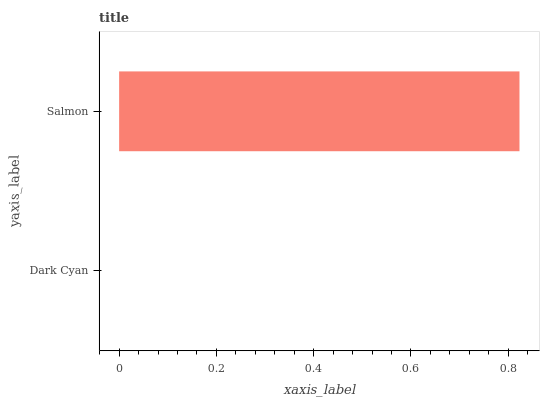Is Dark Cyan the minimum?
Answer yes or no. Yes. Is Salmon the maximum?
Answer yes or no. Yes. Is Salmon the minimum?
Answer yes or no. No. Is Salmon greater than Dark Cyan?
Answer yes or no. Yes. Is Dark Cyan less than Salmon?
Answer yes or no. Yes. Is Dark Cyan greater than Salmon?
Answer yes or no. No. Is Salmon less than Dark Cyan?
Answer yes or no. No. Is Salmon the high median?
Answer yes or no. Yes. Is Dark Cyan the low median?
Answer yes or no. Yes. Is Dark Cyan the high median?
Answer yes or no. No. Is Salmon the low median?
Answer yes or no. No. 